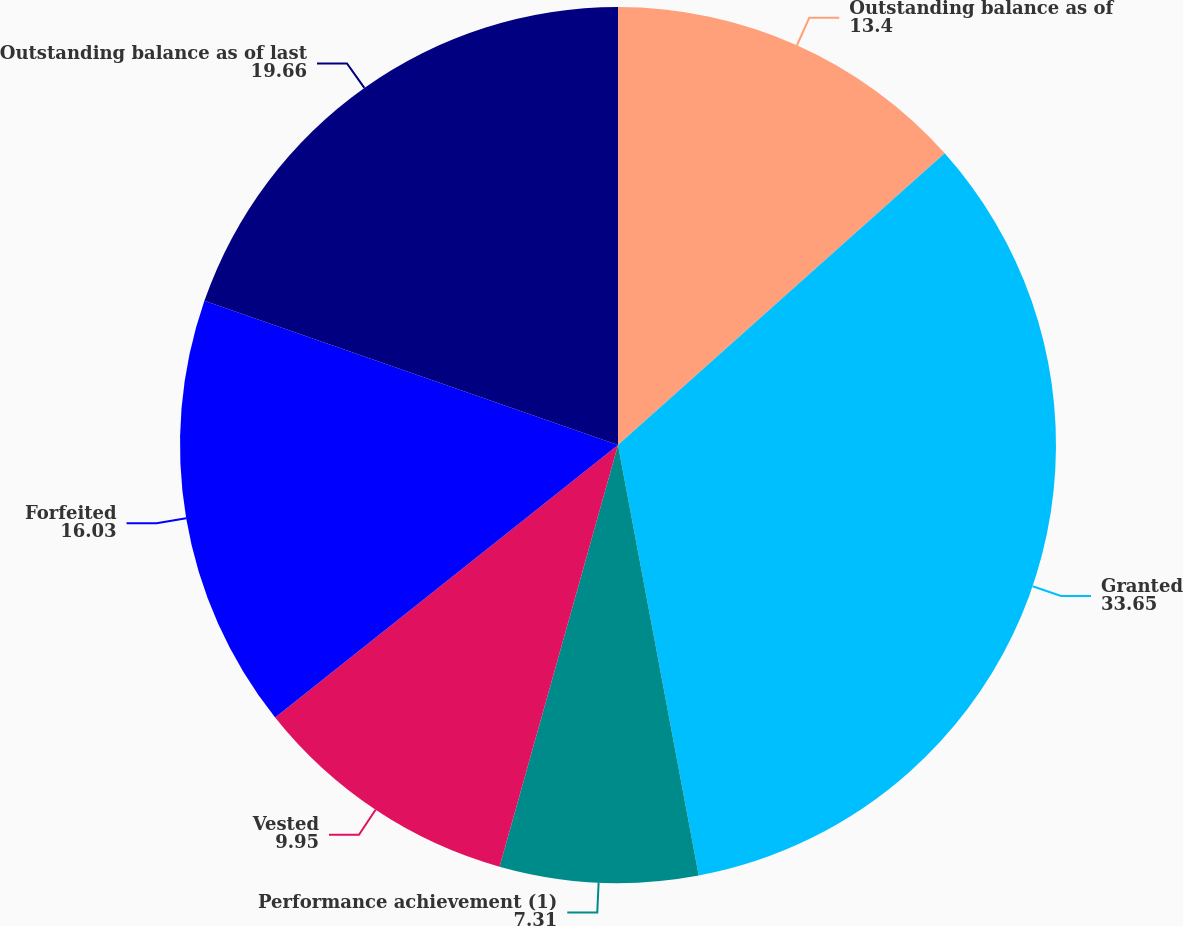Convert chart to OTSL. <chart><loc_0><loc_0><loc_500><loc_500><pie_chart><fcel>Outstanding balance as of<fcel>Granted<fcel>Performance achievement (1)<fcel>Vested<fcel>Forfeited<fcel>Outstanding balance as of last<nl><fcel>13.4%<fcel>33.65%<fcel>7.31%<fcel>9.95%<fcel>16.03%<fcel>19.66%<nl></chart> 